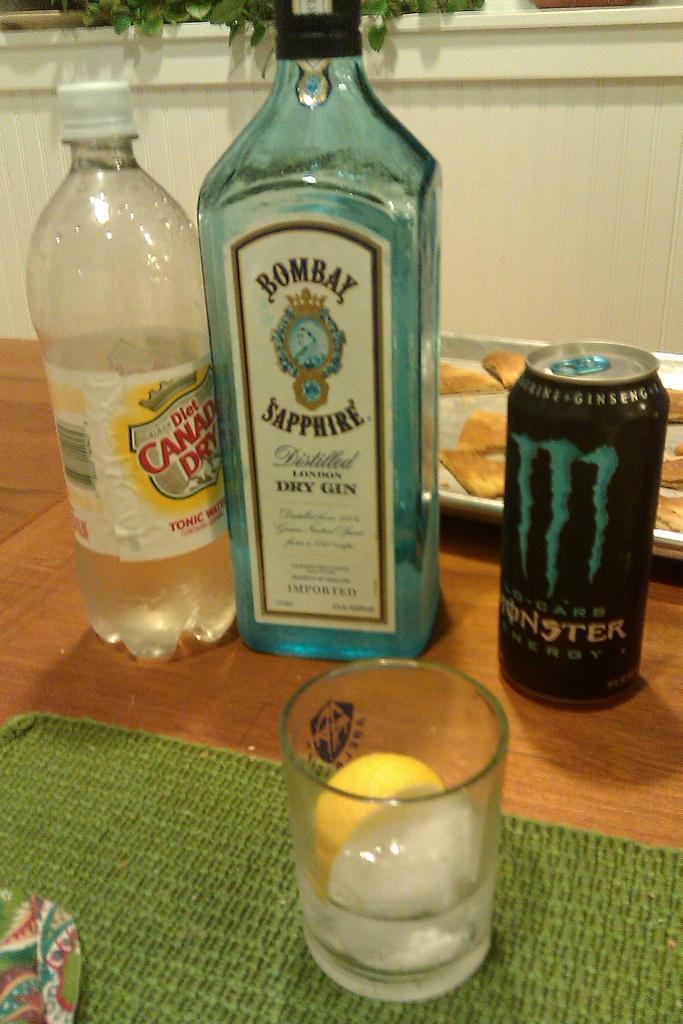In one or two sentences, can you explain what this image depicts? In this image i can see a glass bottle, a plastic bottle, a tin and a wine glass in which there is a ice and a lemon. In the background i can see a tray with biscuits in it , the wall and few plants. 